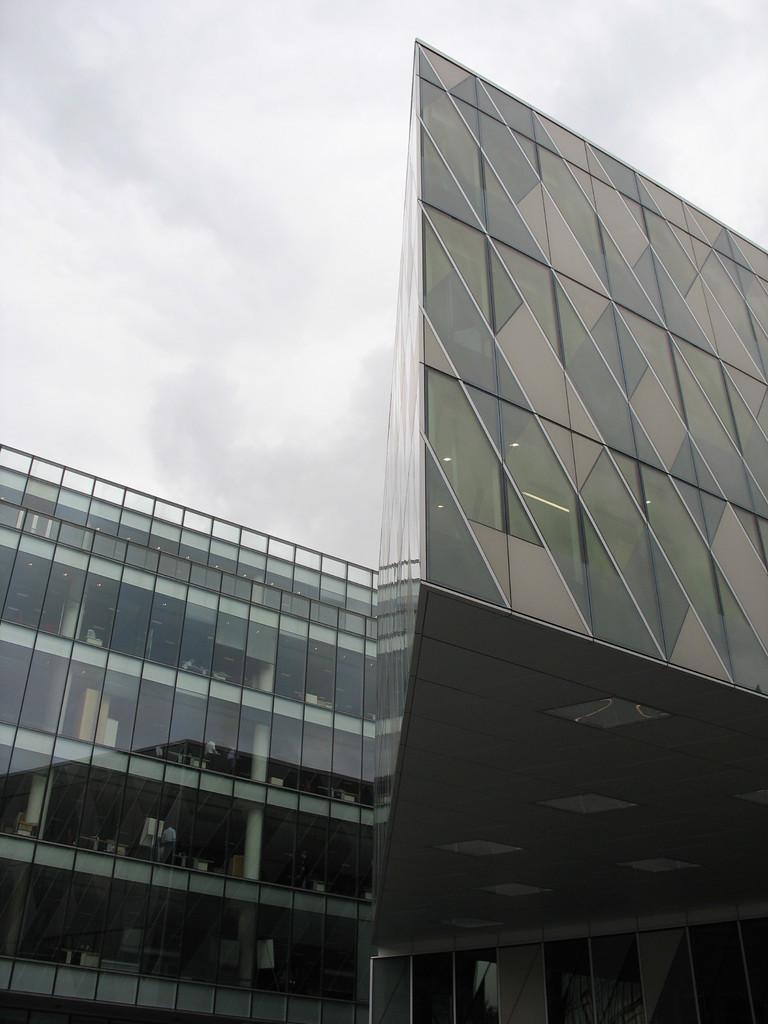Can you describe this image briefly? In this image I can see a glass building. Background sky is in white color 